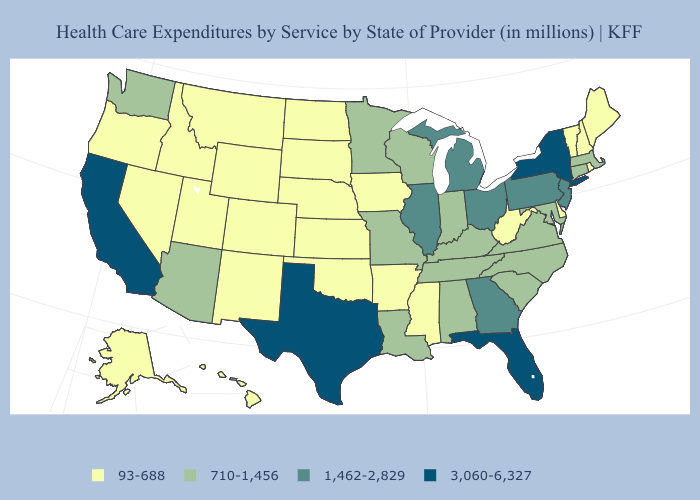Does Nebraska have a lower value than California?
Concise answer only. Yes. Name the states that have a value in the range 3,060-6,327?
Keep it brief. California, Florida, New York, Texas. Does Virginia have a higher value than Tennessee?
Concise answer only. No. What is the highest value in states that border Kansas?
Give a very brief answer. 710-1,456. Name the states that have a value in the range 1,462-2,829?
Write a very short answer. Georgia, Illinois, Michigan, New Jersey, Ohio, Pennsylvania. Does the first symbol in the legend represent the smallest category?
Be succinct. Yes. Which states have the lowest value in the Northeast?
Quick response, please. Maine, New Hampshire, Rhode Island, Vermont. What is the value of Virginia?
Concise answer only. 710-1,456. What is the value of Louisiana?
Give a very brief answer. 710-1,456. Does Texas have the highest value in the South?
Write a very short answer. Yes. How many symbols are there in the legend?
Write a very short answer. 4. What is the value of Maryland?
Write a very short answer. 710-1,456. What is the value of Montana?
Short answer required. 93-688. Does Wyoming have a lower value than Oregon?
Write a very short answer. No. What is the highest value in the Northeast ?
Answer briefly. 3,060-6,327. 